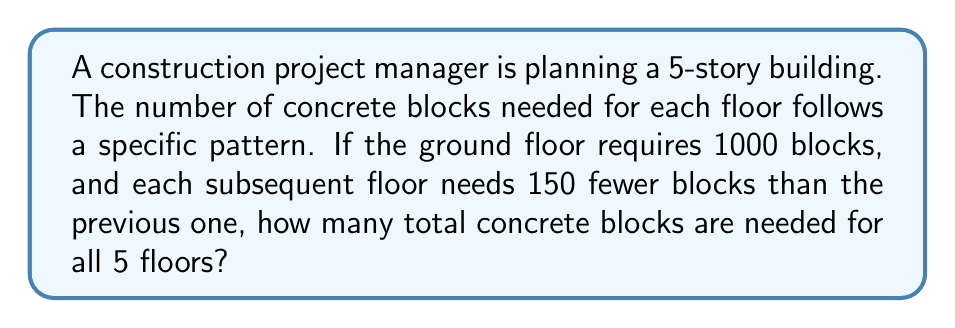Solve this math problem. Let's approach this step-by-step:

1) First, let's identify the sequence of blocks needed for each floor:
   - Ground floor: 1000 blocks
   - 1st floor: 1000 - 150 = 850 blocks
   - 2nd floor: 850 - 150 = 700 blocks
   - 3rd floor: 700 - 150 = 550 blocks
   - 4th floor: 550 - 150 = 400 blocks

2) We can see that this forms an arithmetic sequence with:
   - First term: $a_1 = 1000$
   - Common difference: $d = -150$
   - Number of terms: $n = 5$

3) To find the total number of blocks, we need to find the sum of this arithmetic sequence. We can use the formula:

   $$S_n = \frac{n}{2}(a_1 + a_n)$$

   Where $S_n$ is the sum, $n$ is the number of terms, $a_1$ is the first term, and $a_n$ is the last term.

4) We know $a_1 = 1000$ and $n = 5$. We need to find $a_5$:
   
   $a_5 = a_1 + (n-1)d = 1000 + (5-1)(-150) = 1000 - 600 = 400$

5) Now we can substitute into our sum formula:

   $$S_5 = \frac{5}{2}(1000 + 400) = \frac{5}{2}(1400) = 3500$$

Therefore, the total number of concrete blocks needed for all 5 floors is 3500.
Answer: 3500 blocks 